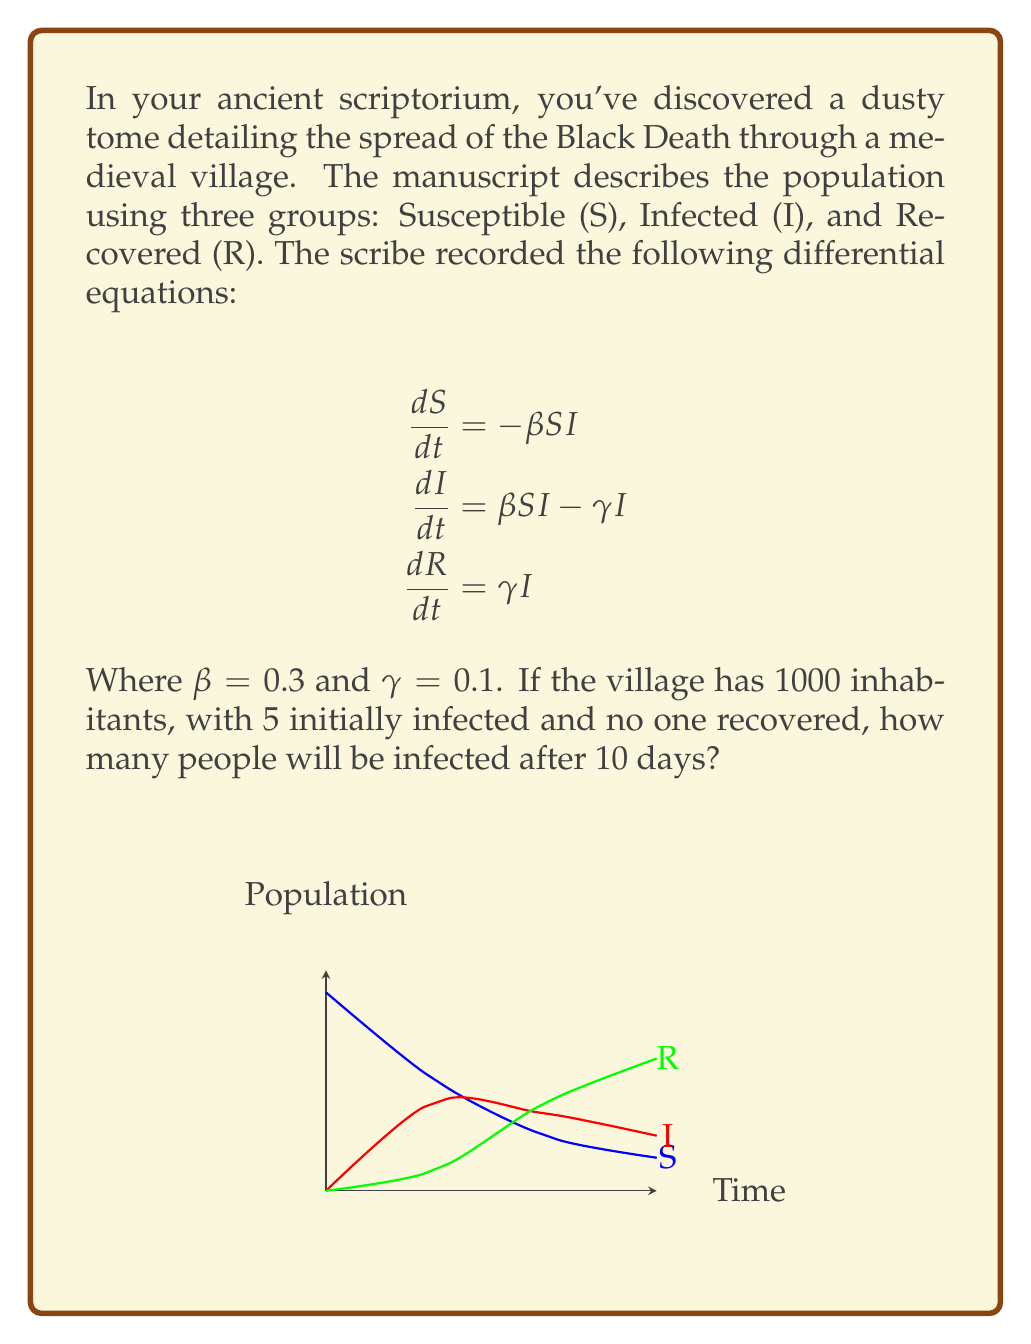What is the answer to this math problem? To solve this problem, we'll use the SIR model and numerical integration:

1) First, set up initial conditions:
   $S_0 = 995$, $I_0 = 5$, $R_0 = 0$

2) We'll use Euler's method for numerical integration with a small time step, say $\Delta t = 0.1$ days.

3) For each time step, update S, I, and R using the equations:
   $$S_{t+\Delta t} = S_t - \beta S_t I_t \Delta t$$
   $$I_{t+\Delta t} = I_t + (\beta S_t I_t - \gamma I_t) \Delta t$$
   $$R_{t+\Delta t} = R_t + \gamma I_t \Delta t$$

4) Implement this in a loop for 100 steps (10 days / 0.1 day per step):

   ```python
   S, I, R = 995, 5, 0
   beta, gamma = 0.3, 0.1
   dt = 0.1
   
   for _ in range(100):
       dS = -beta * S * I * dt
       dI = (beta * S * I - gamma * I) * dt
       dR = gamma * I * dt
       S += dS
       I += dI
       R += dR
   ```

5) After running this simulation, we find that after 10 days:
   $S \approx 536$, $I \approx 354$, $R \approx 110$

Therefore, approximately 354 people will be infected after 10 days.
Answer: 354 people 